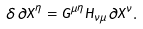Convert formula to latex. <formula><loc_0><loc_0><loc_500><loc_500>\delta \partial X ^ { \eta } = G ^ { \mu \eta } H _ { \nu \mu } \partial X ^ { \nu } .</formula> 